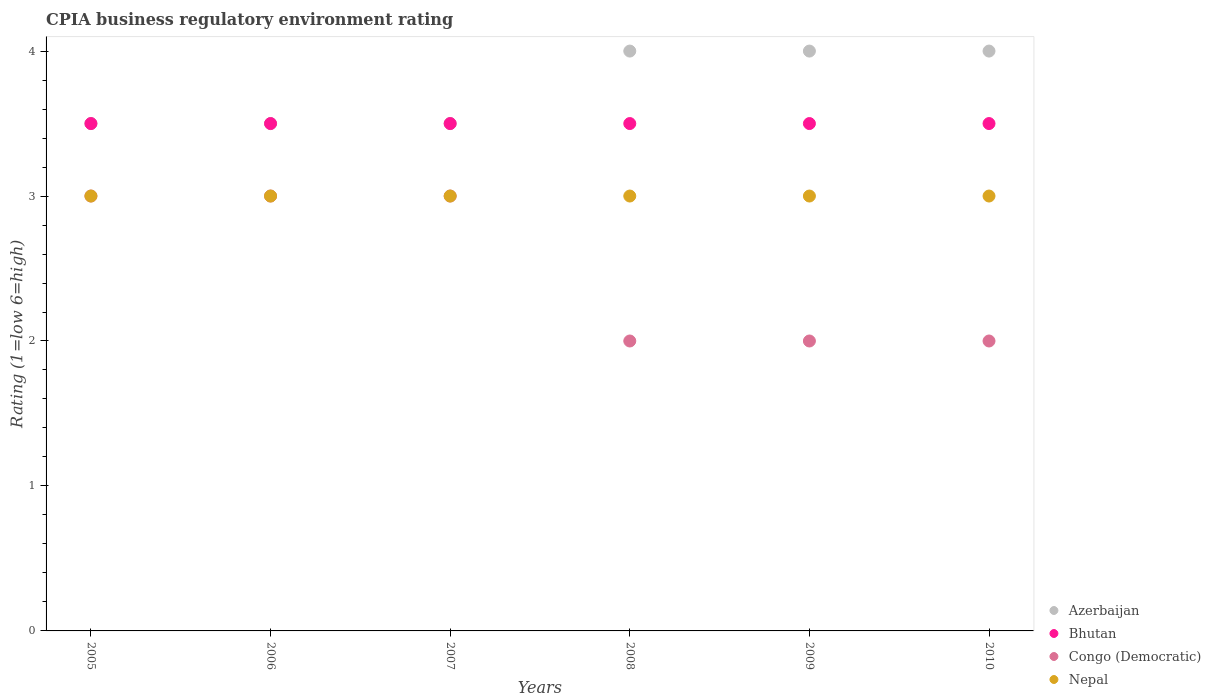Is the number of dotlines equal to the number of legend labels?
Offer a terse response. Yes. What is the CPIA rating in Nepal in 2006?
Your response must be concise. 3. In which year was the CPIA rating in Azerbaijan minimum?
Your answer should be very brief. 2005. What is the difference between the CPIA rating in Nepal in 2008 and that in 2009?
Your response must be concise. 0. What is the average CPIA rating in Azerbaijan per year?
Offer a very short reply. 3.75. What is the ratio of the CPIA rating in Bhutan in 2006 to that in 2007?
Offer a terse response. 1. Is the CPIA rating in Azerbaijan in 2006 less than that in 2007?
Your answer should be compact. No. Is the difference between the CPIA rating in Bhutan in 2007 and 2008 greater than the difference between the CPIA rating in Azerbaijan in 2007 and 2008?
Provide a succinct answer. Yes. In how many years, is the CPIA rating in Congo (Democratic) greater than the average CPIA rating in Congo (Democratic) taken over all years?
Keep it short and to the point. 3. Is it the case that in every year, the sum of the CPIA rating in Congo (Democratic) and CPIA rating in Azerbaijan  is greater than the sum of CPIA rating in Bhutan and CPIA rating in Nepal?
Your answer should be compact. No. Is it the case that in every year, the sum of the CPIA rating in Azerbaijan and CPIA rating in Congo (Democratic)  is greater than the CPIA rating in Nepal?
Your answer should be very brief. Yes. Does the CPIA rating in Bhutan monotonically increase over the years?
Keep it short and to the point. No. Is the CPIA rating in Nepal strictly greater than the CPIA rating in Congo (Democratic) over the years?
Your response must be concise. No. How many years are there in the graph?
Offer a terse response. 6. What is the difference between two consecutive major ticks on the Y-axis?
Keep it short and to the point. 1. Does the graph contain any zero values?
Provide a short and direct response. No. Where does the legend appear in the graph?
Provide a short and direct response. Bottom right. How many legend labels are there?
Offer a terse response. 4. What is the title of the graph?
Provide a short and direct response. CPIA business regulatory environment rating. What is the label or title of the Y-axis?
Provide a succinct answer. Rating (1=low 6=high). What is the Rating (1=low 6=high) in Azerbaijan in 2005?
Offer a terse response. 3.5. What is the Rating (1=low 6=high) of Nepal in 2005?
Provide a succinct answer. 3. What is the Rating (1=low 6=high) in Nepal in 2006?
Your response must be concise. 3. What is the Rating (1=low 6=high) of Azerbaijan in 2007?
Offer a very short reply. 3.5. What is the Rating (1=low 6=high) in Bhutan in 2007?
Your answer should be very brief. 3.5. What is the Rating (1=low 6=high) of Azerbaijan in 2008?
Your answer should be compact. 4. What is the Rating (1=low 6=high) in Nepal in 2008?
Provide a succinct answer. 3. What is the Rating (1=low 6=high) of Azerbaijan in 2009?
Your answer should be very brief. 4. What is the Rating (1=low 6=high) of Bhutan in 2009?
Provide a succinct answer. 3.5. What is the Rating (1=low 6=high) of Congo (Democratic) in 2009?
Provide a succinct answer. 2. What is the Rating (1=low 6=high) in Nepal in 2009?
Provide a succinct answer. 3. What is the Rating (1=low 6=high) of Bhutan in 2010?
Provide a succinct answer. 3.5. What is the Rating (1=low 6=high) of Nepal in 2010?
Give a very brief answer. 3. Across all years, what is the maximum Rating (1=low 6=high) of Bhutan?
Offer a very short reply. 3.5. Across all years, what is the minimum Rating (1=low 6=high) in Congo (Democratic)?
Your response must be concise. 2. What is the difference between the Rating (1=low 6=high) of Azerbaijan in 2005 and that in 2006?
Your answer should be compact. 0. What is the difference between the Rating (1=low 6=high) in Bhutan in 2005 and that in 2006?
Provide a short and direct response. 0. What is the difference between the Rating (1=low 6=high) of Azerbaijan in 2005 and that in 2007?
Your response must be concise. 0. What is the difference between the Rating (1=low 6=high) of Nepal in 2005 and that in 2008?
Keep it short and to the point. 0. What is the difference between the Rating (1=low 6=high) in Nepal in 2005 and that in 2009?
Keep it short and to the point. 0. What is the difference between the Rating (1=low 6=high) in Azerbaijan in 2005 and that in 2010?
Offer a terse response. -0.5. What is the difference between the Rating (1=low 6=high) of Nepal in 2005 and that in 2010?
Offer a very short reply. 0. What is the difference between the Rating (1=low 6=high) of Congo (Democratic) in 2006 and that in 2007?
Provide a short and direct response. 0. What is the difference between the Rating (1=low 6=high) of Nepal in 2006 and that in 2007?
Give a very brief answer. 0. What is the difference between the Rating (1=low 6=high) in Azerbaijan in 2006 and that in 2009?
Provide a succinct answer. -0.5. What is the difference between the Rating (1=low 6=high) of Bhutan in 2006 and that in 2009?
Provide a short and direct response. 0. What is the difference between the Rating (1=low 6=high) in Congo (Democratic) in 2006 and that in 2009?
Provide a succinct answer. 1. What is the difference between the Rating (1=low 6=high) of Bhutan in 2006 and that in 2010?
Keep it short and to the point. 0. What is the difference between the Rating (1=low 6=high) in Congo (Democratic) in 2006 and that in 2010?
Your answer should be very brief. 1. What is the difference between the Rating (1=low 6=high) in Nepal in 2006 and that in 2010?
Your answer should be compact. 0. What is the difference between the Rating (1=low 6=high) in Azerbaijan in 2007 and that in 2008?
Provide a succinct answer. -0.5. What is the difference between the Rating (1=low 6=high) of Congo (Democratic) in 2007 and that in 2008?
Your response must be concise. 1. What is the difference between the Rating (1=low 6=high) in Bhutan in 2007 and that in 2009?
Offer a very short reply. 0. What is the difference between the Rating (1=low 6=high) in Congo (Democratic) in 2007 and that in 2009?
Make the answer very short. 1. What is the difference between the Rating (1=low 6=high) in Nepal in 2007 and that in 2009?
Your answer should be very brief. 0. What is the difference between the Rating (1=low 6=high) in Bhutan in 2007 and that in 2010?
Offer a very short reply. 0. What is the difference between the Rating (1=low 6=high) of Nepal in 2007 and that in 2010?
Your response must be concise. 0. What is the difference between the Rating (1=low 6=high) of Azerbaijan in 2008 and that in 2009?
Offer a terse response. 0. What is the difference between the Rating (1=low 6=high) of Bhutan in 2008 and that in 2009?
Make the answer very short. 0. What is the difference between the Rating (1=low 6=high) of Nepal in 2008 and that in 2009?
Ensure brevity in your answer.  0. What is the difference between the Rating (1=low 6=high) in Azerbaijan in 2008 and that in 2010?
Offer a terse response. 0. What is the difference between the Rating (1=low 6=high) in Congo (Democratic) in 2008 and that in 2010?
Ensure brevity in your answer.  0. What is the difference between the Rating (1=low 6=high) in Nepal in 2008 and that in 2010?
Provide a short and direct response. 0. What is the difference between the Rating (1=low 6=high) in Azerbaijan in 2009 and that in 2010?
Ensure brevity in your answer.  0. What is the difference between the Rating (1=low 6=high) in Congo (Democratic) in 2009 and that in 2010?
Offer a very short reply. 0. What is the difference between the Rating (1=low 6=high) in Azerbaijan in 2005 and the Rating (1=low 6=high) in Bhutan in 2006?
Give a very brief answer. 0. What is the difference between the Rating (1=low 6=high) in Bhutan in 2005 and the Rating (1=low 6=high) in Congo (Democratic) in 2006?
Make the answer very short. 0.5. What is the difference between the Rating (1=low 6=high) of Congo (Democratic) in 2005 and the Rating (1=low 6=high) of Nepal in 2006?
Your answer should be compact. 0. What is the difference between the Rating (1=low 6=high) of Azerbaijan in 2005 and the Rating (1=low 6=high) of Bhutan in 2007?
Make the answer very short. 0. What is the difference between the Rating (1=low 6=high) of Azerbaijan in 2005 and the Rating (1=low 6=high) of Congo (Democratic) in 2007?
Ensure brevity in your answer.  0.5. What is the difference between the Rating (1=low 6=high) in Azerbaijan in 2005 and the Rating (1=low 6=high) in Nepal in 2007?
Ensure brevity in your answer.  0.5. What is the difference between the Rating (1=low 6=high) in Bhutan in 2005 and the Rating (1=low 6=high) in Congo (Democratic) in 2007?
Give a very brief answer. 0.5. What is the difference between the Rating (1=low 6=high) in Congo (Democratic) in 2005 and the Rating (1=low 6=high) in Nepal in 2008?
Your response must be concise. 0. What is the difference between the Rating (1=low 6=high) of Azerbaijan in 2005 and the Rating (1=low 6=high) of Nepal in 2009?
Provide a succinct answer. 0.5. What is the difference between the Rating (1=low 6=high) in Bhutan in 2005 and the Rating (1=low 6=high) in Congo (Democratic) in 2009?
Your answer should be very brief. 1.5. What is the difference between the Rating (1=low 6=high) in Azerbaijan in 2005 and the Rating (1=low 6=high) in Nepal in 2010?
Provide a short and direct response. 0.5. What is the difference between the Rating (1=low 6=high) in Azerbaijan in 2006 and the Rating (1=low 6=high) in Bhutan in 2007?
Make the answer very short. 0. What is the difference between the Rating (1=low 6=high) in Azerbaijan in 2006 and the Rating (1=low 6=high) in Bhutan in 2008?
Keep it short and to the point. 0. What is the difference between the Rating (1=low 6=high) of Azerbaijan in 2006 and the Rating (1=low 6=high) of Nepal in 2008?
Ensure brevity in your answer.  0.5. What is the difference between the Rating (1=low 6=high) of Bhutan in 2006 and the Rating (1=low 6=high) of Nepal in 2008?
Ensure brevity in your answer.  0.5. What is the difference between the Rating (1=low 6=high) of Bhutan in 2006 and the Rating (1=low 6=high) of Nepal in 2009?
Provide a short and direct response. 0.5. What is the difference between the Rating (1=low 6=high) of Congo (Democratic) in 2006 and the Rating (1=low 6=high) of Nepal in 2009?
Provide a succinct answer. 0. What is the difference between the Rating (1=low 6=high) of Azerbaijan in 2006 and the Rating (1=low 6=high) of Congo (Democratic) in 2010?
Offer a very short reply. 1.5. What is the difference between the Rating (1=low 6=high) of Congo (Democratic) in 2006 and the Rating (1=low 6=high) of Nepal in 2010?
Provide a succinct answer. 0. What is the difference between the Rating (1=low 6=high) of Azerbaijan in 2007 and the Rating (1=low 6=high) of Bhutan in 2008?
Give a very brief answer. 0. What is the difference between the Rating (1=low 6=high) of Bhutan in 2007 and the Rating (1=low 6=high) of Nepal in 2008?
Your answer should be compact. 0.5. What is the difference between the Rating (1=low 6=high) of Azerbaijan in 2007 and the Rating (1=low 6=high) of Bhutan in 2009?
Offer a very short reply. 0. What is the difference between the Rating (1=low 6=high) in Azerbaijan in 2007 and the Rating (1=low 6=high) in Nepal in 2009?
Your response must be concise. 0.5. What is the difference between the Rating (1=low 6=high) of Bhutan in 2007 and the Rating (1=low 6=high) of Congo (Democratic) in 2009?
Your answer should be very brief. 1.5. What is the difference between the Rating (1=low 6=high) of Bhutan in 2007 and the Rating (1=low 6=high) of Nepal in 2009?
Your answer should be compact. 0.5. What is the difference between the Rating (1=low 6=high) of Congo (Democratic) in 2007 and the Rating (1=low 6=high) of Nepal in 2009?
Your answer should be very brief. 0. What is the difference between the Rating (1=low 6=high) of Azerbaijan in 2007 and the Rating (1=low 6=high) of Nepal in 2010?
Provide a short and direct response. 0.5. What is the difference between the Rating (1=low 6=high) in Bhutan in 2007 and the Rating (1=low 6=high) in Nepal in 2010?
Ensure brevity in your answer.  0.5. What is the difference between the Rating (1=low 6=high) in Bhutan in 2008 and the Rating (1=low 6=high) in Nepal in 2009?
Provide a succinct answer. 0.5. What is the difference between the Rating (1=low 6=high) of Congo (Democratic) in 2008 and the Rating (1=low 6=high) of Nepal in 2009?
Your response must be concise. -1. What is the difference between the Rating (1=low 6=high) in Azerbaijan in 2008 and the Rating (1=low 6=high) in Bhutan in 2010?
Offer a very short reply. 0.5. What is the difference between the Rating (1=low 6=high) in Bhutan in 2009 and the Rating (1=low 6=high) in Nepal in 2010?
Provide a short and direct response. 0.5. What is the difference between the Rating (1=low 6=high) of Congo (Democratic) in 2009 and the Rating (1=low 6=high) of Nepal in 2010?
Offer a terse response. -1. What is the average Rating (1=low 6=high) of Azerbaijan per year?
Keep it short and to the point. 3.75. What is the average Rating (1=low 6=high) of Bhutan per year?
Give a very brief answer. 3.5. What is the average Rating (1=low 6=high) of Congo (Democratic) per year?
Keep it short and to the point. 2.5. What is the average Rating (1=low 6=high) of Nepal per year?
Provide a short and direct response. 3. In the year 2005, what is the difference between the Rating (1=low 6=high) of Azerbaijan and Rating (1=low 6=high) of Congo (Democratic)?
Your answer should be very brief. 0.5. In the year 2005, what is the difference between the Rating (1=low 6=high) of Bhutan and Rating (1=low 6=high) of Congo (Democratic)?
Provide a succinct answer. 0.5. In the year 2005, what is the difference between the Rating (1=low 6=high) of Bhutan and Rating (1=low 6=high) of Nepal?
Ensure brevity in your answer.  0.5. In the year 2006, what is the difference between the Rating (1=low 6=high) in Bhutan and Rating (1=low 6=high) in Congo (Democratic)?
Offer a very short reply. 0.5. In the year 2006, what is the difference between the Rating (1=low 6=high) in Congo (Democratic) and Rating (1=low 6=high) in Nepal?
Ensure brevity in your answer.  0. In the year 2007, what is the difference between the Rating (1=low 6=high) of Azerbaijan and Rating (1=low 6=high) of Bhutan?
Keep it short and to the point. 0. In the year 2007, what is the difference between the Rating (1=low 6=high) of Azerbaijan and Rating (1=low 6=high) of Congo (Democratic)?
Ensure brevity in your answer.  0.5. In the year 2007, what is the difference between the Rating (1=low 6=high) of Bhutan and Rating (1=low 6=high) of Nepal?
Your answer should be very brief. 0.5. In the year 2008, what is the difference between the Rating (1=low 6=high) of Azerbaijan and Rating (1=low 6=high) of Nepal?
Make the answer very short. 1. In the year 2008, what is the difference between the Rating (1=low 6=high) of Bhutan and Rating (1=low 6=high) of Congo (Democratic)?
Keep it short and to the point. 1.5. In the year 2008, what is the difference between the Rating (1=low 6=high) of Bhutan and Rating (1=low 6=high) of Nepal?
Ensure brevity in your answer.  0.5. In the year 2009, what is the difference between the Rating (1=low 6=high) of Azerbaijan and Rating (1=low 6=high) of Bhutan?
Provide a succinct answer. 0.5. In the year 2009, what is the difference between the Rating (1=low 6=high) in Azerbaijan and Rating (1=low 6=high) in Congo (Democratic)?
Offer a terse response. 2. In the year 2009, what is the difference between the Rating (1=low 6=high) of Azerbaijan and Rating (1=low 6=high) of Nepal?
Your answer should be compact. 1. In the year 2009, what is the difference between the Rating (1=low 6=high) of Bhutan and Rating (1=low 6=high) of Congo (Democratic)?
Provide a short and direct response. 1.5. In the year 2009, what is the difference between the Rating (1=low 6=high) of Bhutan and Rating (1=low 6=high) of Nepal?
Your response must be concise. 0.5. In the year 2009, what is the difference between the Rating (1=low 6=high) in Congo (Democratic) and Rating (1=low 6=high) in Nepal?
Offer a very short reply. -1. In the year 2010, what is the difference between the Rating (1=low 6=high) of Azerbaijan and Rating (1=low 6=high) of Bhutan?
Give a very brief answer. 0.5. In the year 2010, what is the difference between the Rating (1=low 6=high) of Azerbaijan and Rating (1=low 6=high) of Nepal?
Ensure brevity in your answer.  1. In the year 2010, what is the difference between the Rating (1=low 6=high) in Bhutan and Rating (1=low 6=high) in Congo (Democratic)?
Provide a short and direct response. 1.5. In the year 2010, what is the difference between the Rating (1=low 6=high) in Congo (Democratic) and Rating (1=low 6=high) in Nepal?
Provide a succinct answer. -1. What is the ratio of the Rating (1=low 6=high) in Azerbaijan in 2005 to that in 2006?
Provide a succinct answer. 1. What is the ratio of the Rating (1=low 6=high) in Congo (Democratic) in 2005 to that in 2006?
Your answer should be very brief. 1. What is the ratio of the Rating (1=low 6=high) of Nepal in 2005 to that in 2006?
Keep it short and to the point. 1. What is the ratio of the Rating (1=low 6=high) of Azerbaijan in 2005 to that in 2007?
Give a very brief answer. 1. What is the ratio of the Rating (1=low 6=high) in Nepal in 2005 to that in 2007?
Provide a short and direct response. 1. What is the ratio of the Rating (1=low 6=high) in Azerbaijan in 2005 to that in 2008?
Ensure brevity in your answer.  0.88. What is the ratio of the Rating (1=low 6=high) in Bhutan in 2005 to that in 2008?
Your response must be concise. 1. What is the ratio of the Rating (1=low 6=high) in Congo (Democratic) in 2005 to that in 2008?
Offer a terse response. 1.5. What is the ratio of the Rating (1=low 6=high) in Congo (Democratic) in 2005 to that in 2009?
Provide a succinct answer. 1.5. What is the ratio of the Rating (1=low 6=high) of Azerbaijan in 2005 to that in 2010?
Make the answer very short. 0.88. What is the ratio of the Rating (1=low 6=high) of Congo (Democratic) in 2005 to that in 2010?
Give a very brief answer. 1.5. What is the ratio of the Rating (1=low 6=high) in Nepal in 2005 to that in 2010?
Offer a very short reply. 1. What is the ratio of the Rating (1=low 6=high) of Congo (Democratic) in 2006 to that in 2007?
Provide a short and direct response. 1. What is the ratio of the Rating (1=low 6=high) of Nepal in 2006 to that in 2007?
Ensure brevity in your answer.  1. What is the ratio of the Rating (1=low 6=high) in Azerbaijan in 2006 to that in 2008?
Provide a succinct answer. 0.88. What is the ratio of the Rating (1=low 6=high) in Bhutan in 2006 to that in 2008?
Offer a terse response. 1. What is the ratio of the Rating (1=low 6=high) in Azerbaijan in 2006 to that in 2009?
Offer a terse response. 0.88. What is the ratio of the Rating (1=low 6=high) in Bhutan in 2006 to that in 2009?
Your answer should be compact. 1. What is the ratio of the Rating (1=low 6=high) in Congo (Democratic) in 2006 to that in 2009?
Your answer should be very brief. 1.5. What is the ratio of the Rating (1=low 6=high) of Nepal in 2006 to that in 2009?
Provide a short and direct response. 1. What is the ratio of the Rating (1=low 6=high) of Azerbaijan in 2006 to that in 2010?
Your response must be concise. 0.88. What is the ratio of the Rating (1=low 6=high) in Nepal in 2006 to that in 2010?
Offer a very short reply. 1. What is the ratio of the Rating (1=low 6=high) of Azerbaijan in 2007 to that in 2008?
Your answer should be compact. 0.88. What is the ratio of the Rating (1=low 6=high) in Congo (Democratic) in 2007 to that in 2008?
Give a very brief answer. 1.5. What is the ratio of the Rating (1=low 6=high) in Nepal in 2007 to that in 2008?
Offer a terse response. 1. What is the ratio of the Rating (1=low 6=high) of Bhutan in 2007 to that in 2009?
Ensure brevity in your answer.  1. What is the ratio of the Rating (1=low 6=high) of Nepal in 2007 to that in 2009?
Offer a terse response. 1. What is the ratio of the Rating (1=low 6=high) of Azerbaijan in 2008 to that in 2009?
Offer a very short reply. 1. What is the ratio of the Rating (1=low 6=high) in Azerbaijan in 2008 to that in 2010?
Make the answer very short. 1. What is the ratio of the Rating (1=low 6=high) in Bhutan in 2008 to that in 2010?
Give a very brief answer. 1. What is the ratio of the Rating (1=low 6=high) of Bhutan in 2009 to that in 2010?
Provide a succinct answer. 1. What is the ratio of the Rating (1=low 6=high) in Congo (Democratic) in 2009 to that in 2010?
Keep it short and to the point. 1. What is the difference between the highest and the second highest Rating (1=low 6=high) in Azerbaijan?
Make the answer very short. 0. What is the difference between the highest and the second highest Rating (1=low 6=high) of Bhutan?
Keep it short and to the point. 0. What is the difference between the highest and the second highest Rating (1=low 6=high) in Congo (Democratic)?
Offer a terse response. 0. What is the difference between the highest and the lowest Rating (1=low 6=high) of Azerbaijan?
Ensure brevity in your answer.  0.5. What is the difference between the highest and the lowest Rating (1=low 6=high) in Nepal?
Ensure brevity in your answer.  0. 